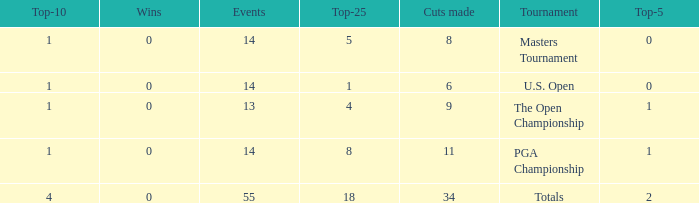Could you parse the entire table as a dict? {'header': ['Top-10', 'Wins', 'Events', 'Top-25', 'Cuts made', 'Tournament', 'Top-5'], 'rows': [['1', '0', '14', '5', '8', 'Masters Tournament', '0'], ['1', '0', '14', '1', '6', 'U.S. Open', '0'], ['1', '0', '13', '4', '9', 'The Open Championship', '1'], ['1', '0', '14', '8', '11', 'PGA Championship', '1'], ['4', '0', '55', '18', '34', 'Totals', '2']]} What is the average top-5 when the cuts made is more than 34? None. 